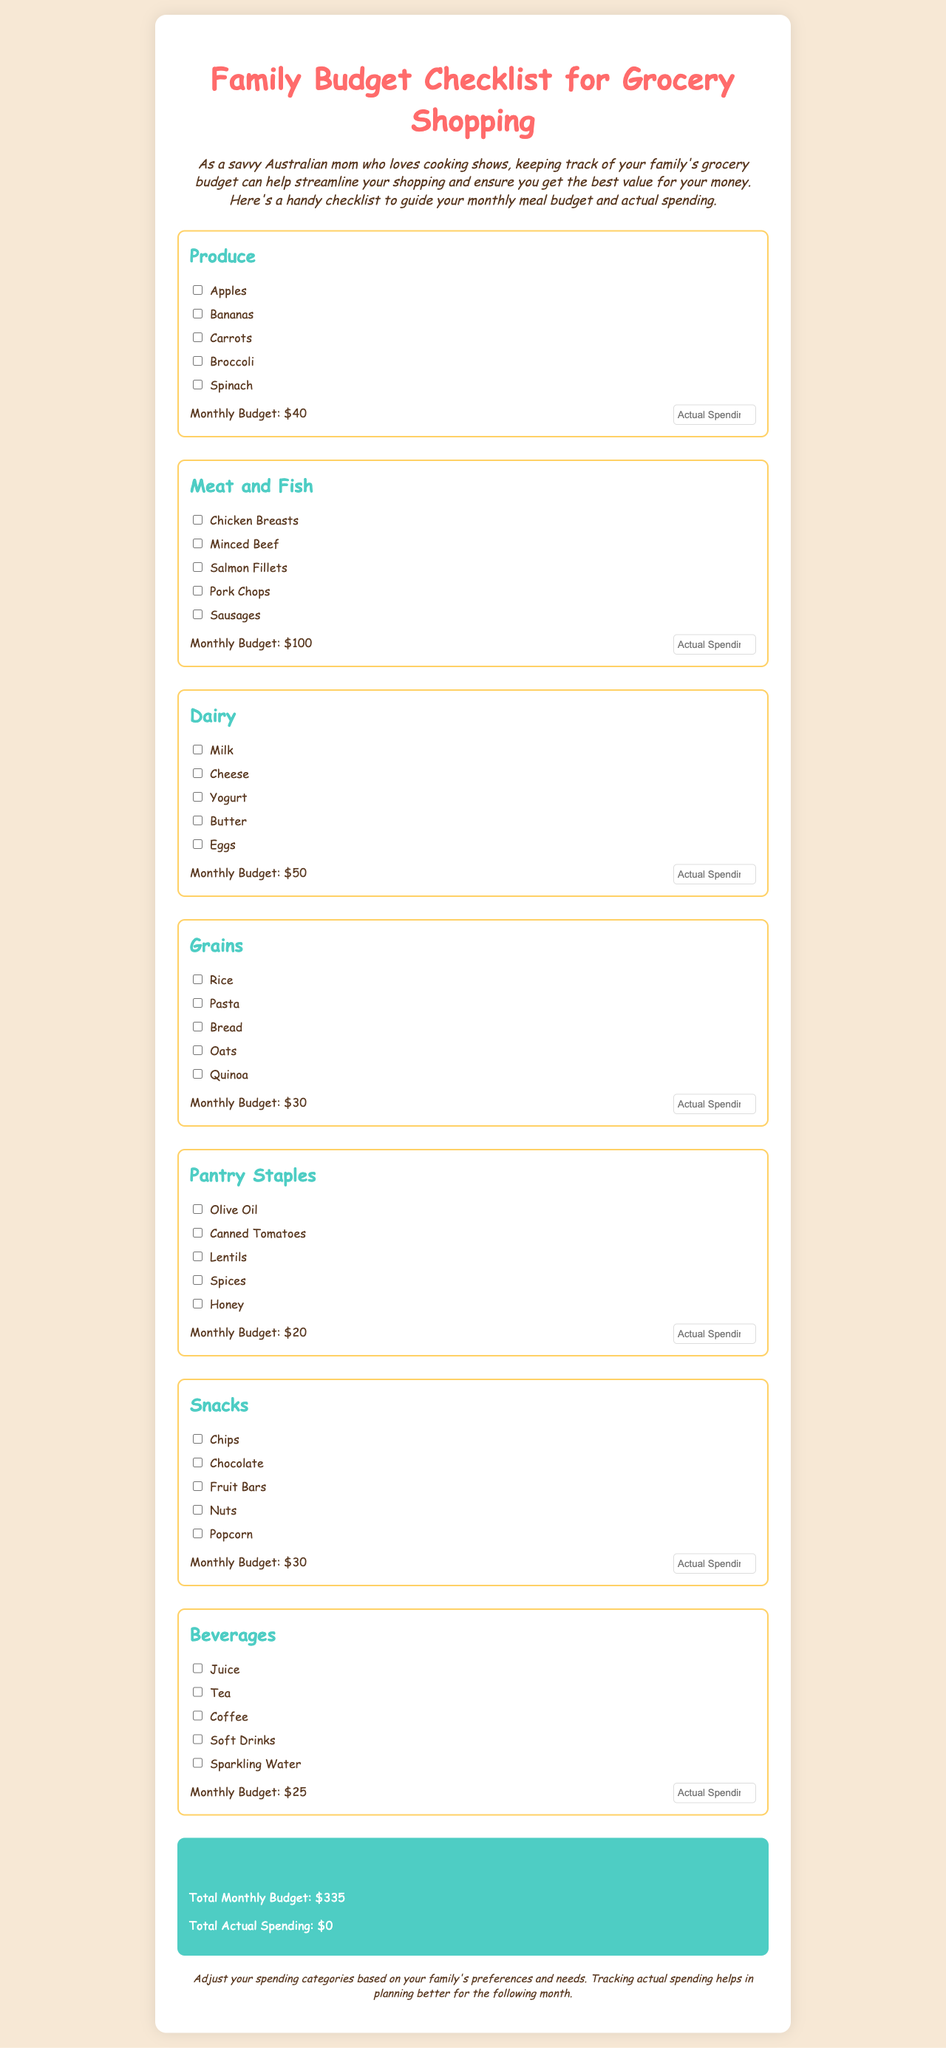what is the monthly budget for produce? The monthly budget for produce is specified in the document as $40.
Answer: $40 how many categories are there in the grocery checklist? The document lists a total of seven categories: Produce, Meat and Fish, Dairy, Grains, Pantry Staples, Snacks, and Beverages.
Answer: seven what is the total monthly budget for groceries? The total monthly budget is calculated from all categories combined and is stated as $335.
Answer: $335 what is the actual spending input field for snacks? The input field for snacks is identified in the document as "snacksActual".
Answer: snacksActual which category has a monthly budget of $100? The category with a monthly budget of $100 is Meat and Fish as detailed in the document.
Answer: Meat and Fish what is one item listed under dairy? One of the items listed under dairy is Milk.
Answer: Milk what is the budget for beverages? The budget for beverages is stated in the document as $25.
Answer: $25 which item is checked for pantry staples? The document does not show checked items, but you can check them based on your needs.
Answer: Not applicable what color is the total section background? The total section has a background color of #4ecdc4 as mentioned in the style.
Answer: #4ecdc4 